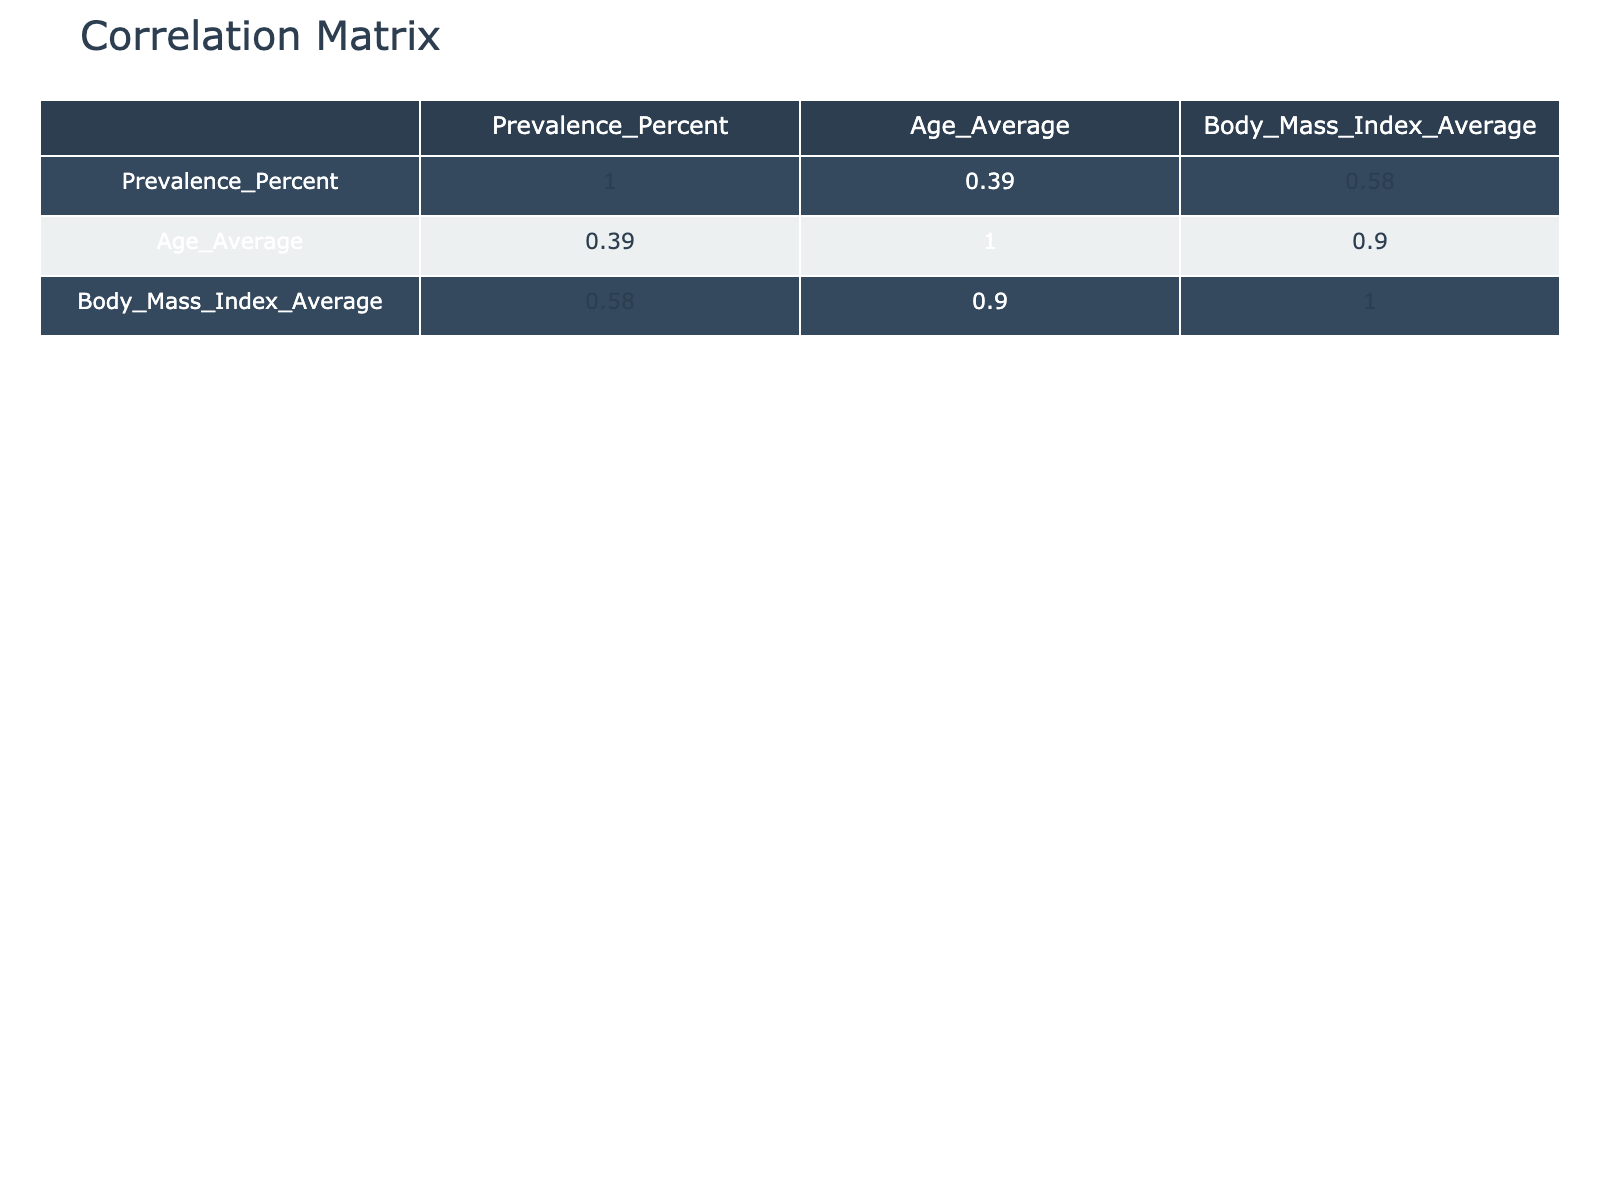What is the prevalence of hypertension among workers in non-automated environments? From the table, the prevalence of hypertension for non-automated workers is directly listed as 30.2%.
Answer: 30.2% Which chronic condition has the highest prevalence in automated environments? By comparing the prevalence percentages listed for each chronic condition in the automated category, hypertension has the highest prevalence at 22.5%.
Answer: Hypertension What is the average age of workers with depression in automated environments? The table shows that the average age for workers with depression in automated environments is 47 years old.
Answer: 47 Is the prevalence of chronic fatigue syndrome higher in automated or non-automated environments? Looking at the prevalence values, chronic fatigue syndrome is 9.8% in automated environments and 13.4% in non-automated environments, showing that it's higher in non-automated environments.
Answer: Non-automated What is the difference in the average body mass index between workers with diabetes in automated and non-automated environments? The average body mass index for automated workers with diabetes is 28.1, and for non-automated workers is 30.2. The difference is 30.2 - 28.1 = 2.1.
Answer: 2.1 What percentage of workers in automated environments suffer from anxiety disorder? The prevalence of anxiety disorder among workers in automated environments is provided in the table as 18.9%.
Answer: 18.9% Is it true that the average age of workers with chronic fatigue syndrome is the same in both environments? The average age for chronic fatigue syndrome in automated environments is 44, while it is 48 in non-automated environments, so the statement is false.
Answer: False Which worker environment has a higher prevalence of depression and by how much? The prevalence of depression in automated environments is listed as 12.7% and in non-automated environments as 17.5%. The difference is 17.5% - 12.7% = 4.8%, indicating non-automated environments have a higher prevalence by this margin.
Answer: Non-automated; 4.8% What is the prevalence of anxiety disorder among workers in non-automated environments compared to those in automated environments? For non-automated workers, the prevalence is 25.3%, while for automated workers, it is 18.9%. Non-automated workers experience a higher prevalence of anxiety disorder by 25.3% - 18.9% = 6.4%.
Answer: Non-automated; 6.4% higher 